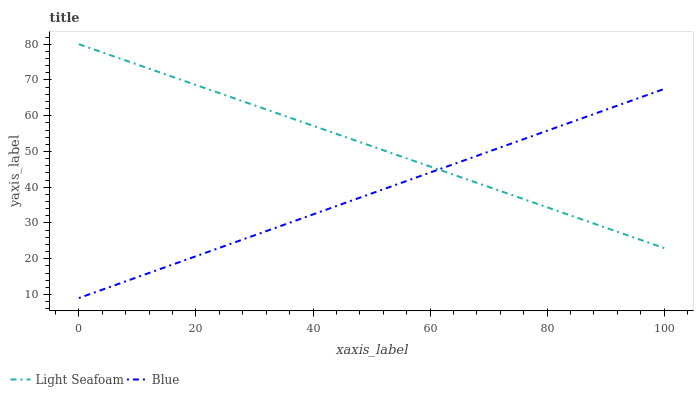Does Blue have the minimum area under the curve?
Answer yes or no. Yes. Does Light Seafoam have the maximum area under the curve?
Answer yes or no. Yes. Does Light Seafoam have the minimum area under the curve?
Answer yes or no. No. Is Blue the smoothest?
Answer yes or no. Yes. Is Light Seafoam the roughest?
Answer yes or no. Yes. Is Light Seafoam the smoothest?
Answer yes or no. No. Does Blue have the lowest value?
Answer yes or no. Yes. Does Light Seafoam have the lowest value?
Answer yes or no. No. Does Light Seafoam have the highest value?
Answer yes or no. Yes. Does Blue intersect Light Seafoam?
Answer yes or no. Yes. Is Blue less than Light Seafoam?
Answer yes or no. No. Is Blue greater than Light Seafoam?
Answer yes or no. No. 